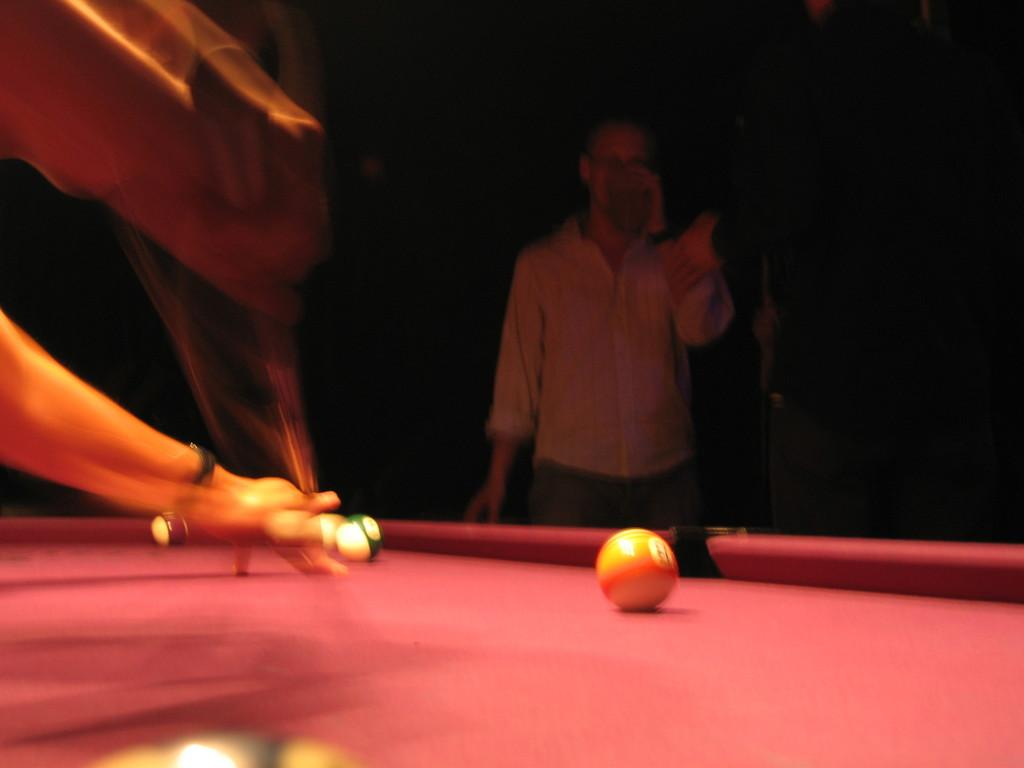How many people are in the image? There are persons standing in the image. What is the surface on which the persons are standing? The persons are standing on the floor. What type of table can be seen in the image? There is a billiards table in the image. How many brothers are playing billiards together in the image? There is no information about brothers or any specific individuals playing billiards in the image. 